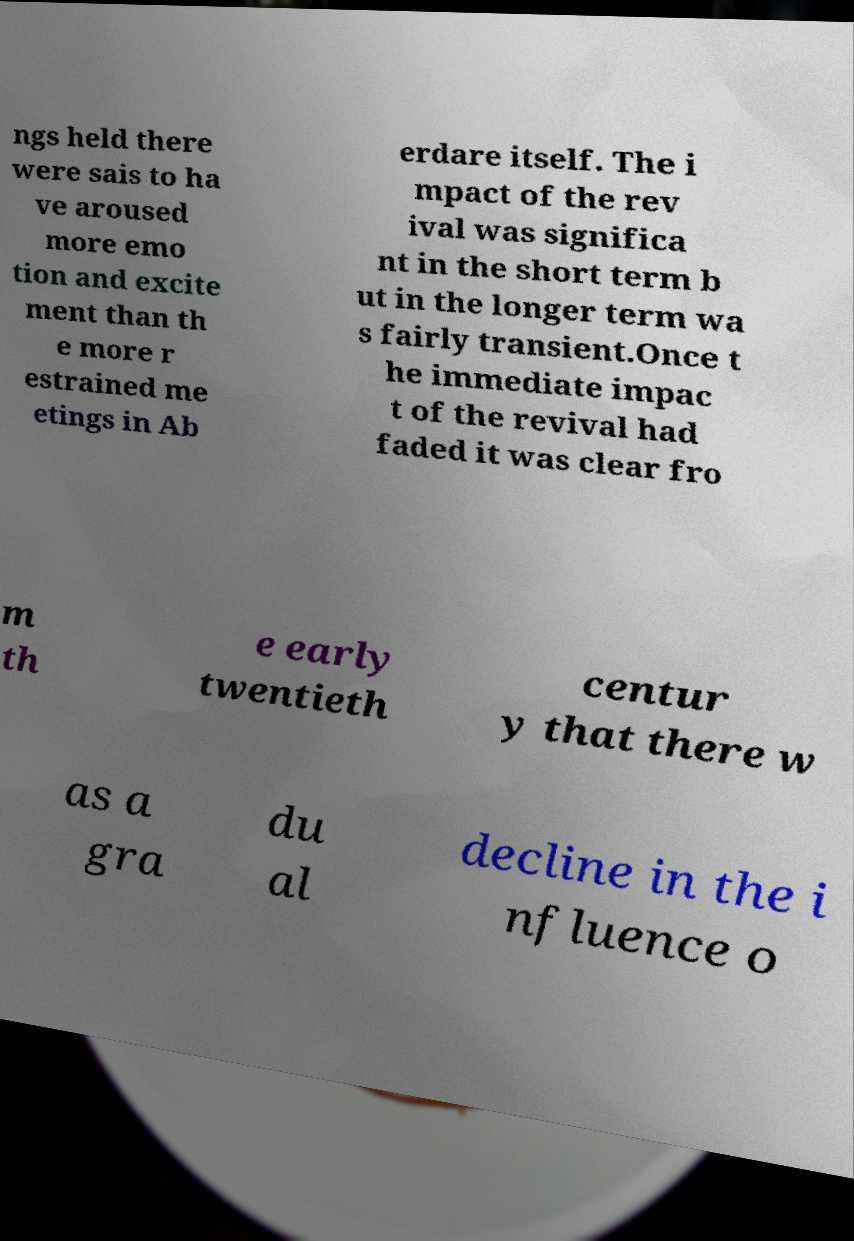Can you read and provide the text displayed in the image?This photo seems to have some interesting text. Can you extract and type it out for me? ngs held there were sais to ha ve aroused more emo tion and excite ment than th e more r estrained me etings in Ab erdare itself. The i mpact of the rev ival was significa nt in the short term b ut in the longer term wa s fairly transient.Once t he immediate impac t of the revival had faded it was clear fro m th e early twentieth centur y that there w as a gra du al decline in the i nfluence o 